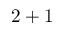<formula> <loc_0><loc_0><loc_500><loc_500>2 + 1</formula> 